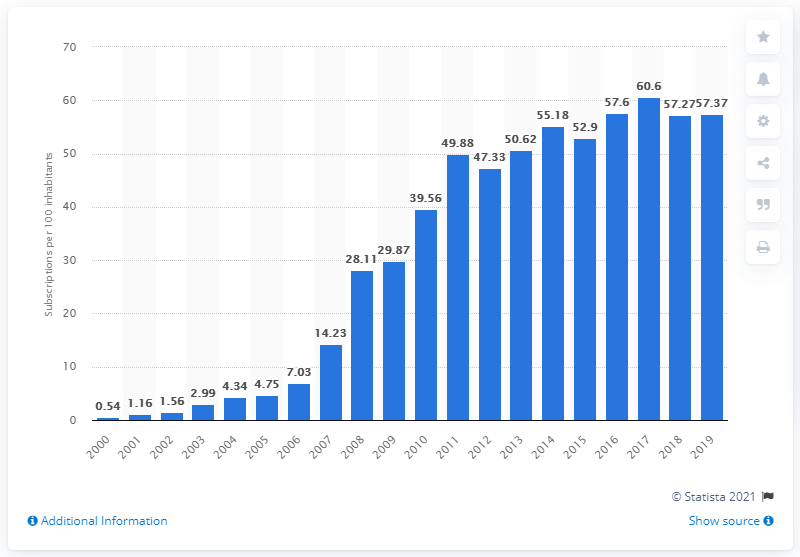Specify some key components in this picture. During the period between 2000 and 2019, there were an average of 57.37 mobile subscriptions registered for every 100 people in Uganda. 